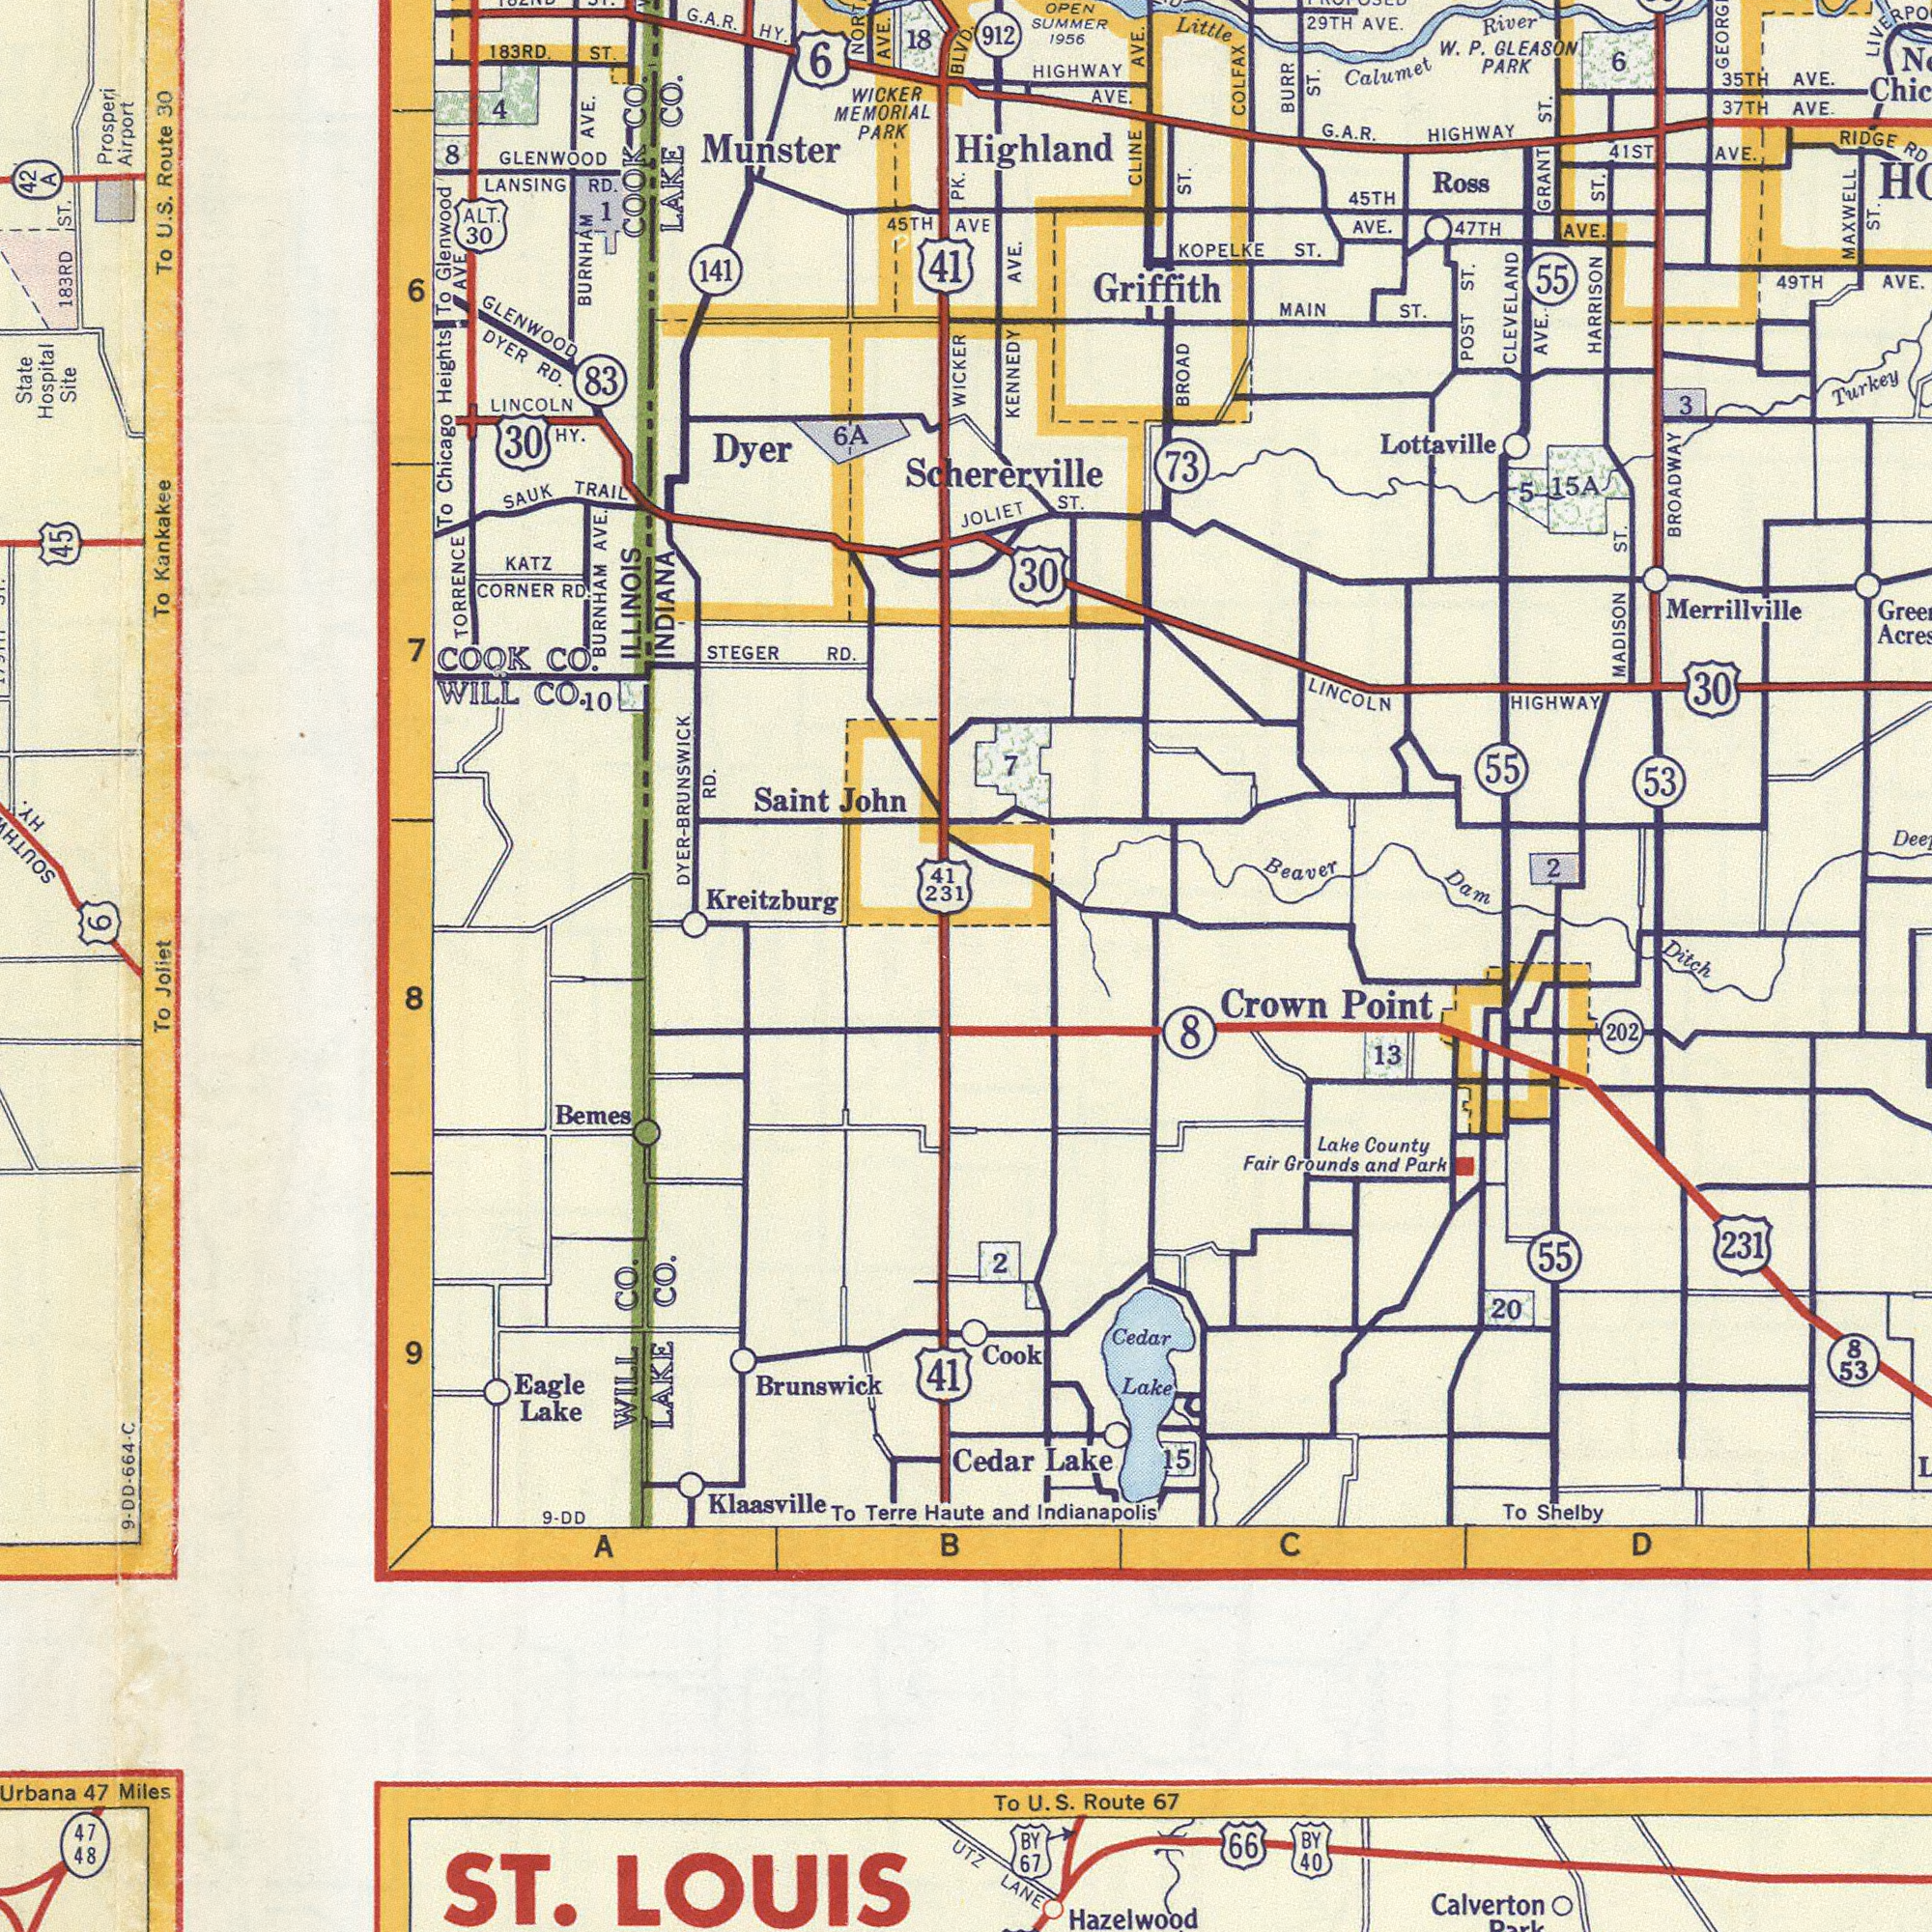What text can you see in the bottom-right section? and Indianapolis Hazelwood LANE Crown Point 231 Calverton Cedar Lake 8 53 To Shelby 66 To U. S. Route 67 BY 67 Cedar Lake Cook BY 40 15 Lake County Fair Grounds and Park 55 2 8 20 D C 13 202 What text can you see in the top-right section? Schererville Merrillville G. A. R. HIGHWAY HARRISON ST. BROADWAY CLEVELAND AVE. MADISON ST. HIGHWAY AVE. Lottaville BROAD ST. Ross W. P. GLEASON PARK POST ST. Highland KOPELKE ST. KENNEDY AVE. GRANT ST. AVE. 73 LINCOLN HIGHWAY Little Calumet River MAXWELL ST. AVE. 53 RIDGE RD BURR ST. COLFAX Beaver Dam Ditch 30 47 TH AVE. CLINE AVE. 49 TH AVE. Turkey MAIN ST. 45 TH AVE. 912 6 29 TH AVE. 30 55 JOLIET ST. 41 ST AVE. 2 3 55 OPEN SUMMER 1956 5 VE 7 Griffith 15 A What text is shown in the top-left quadrant? Kreitzburg Munster ILLINOIS INDIANA To Kankakee Saint John BURNHAM AVE. DYER-BUUNSWIK RD. To Chicago Heights TORRENCE GLENWOOD LINCOLN HY. AVE. WILL CO. 45 183 RD ST. 141 Prosperi Airport CORNER RD. Dyer To U. S. Route 30 LAKE CO. WICKER MEMORIAL PARK COOK CO. LANSING RD. SAUK TRAIL STEGER RD. 6 A BURNHAM AVE. DYER RD. KATZ 7 ALT. 30 State Hospital Site 41 231 To Glenwood AVE 183 RD. ST. 83 GLENWOOD 41 4 G. A. R. HY. 6 30 WICKER PK. 6 8 18 COOK CO. BLVD. 45 TH Joliet 10 1 42 A HY. 6 What text is visible in the lower-left corner? ST. LOUIS Brunswick To Klaasville Bemes WILL CO. LAKE CO. 41 47 Miles Eagle Lake To Terre Haute 8 9 B 48 A 47 UTZ 9- DD- 664- C 9- DD 